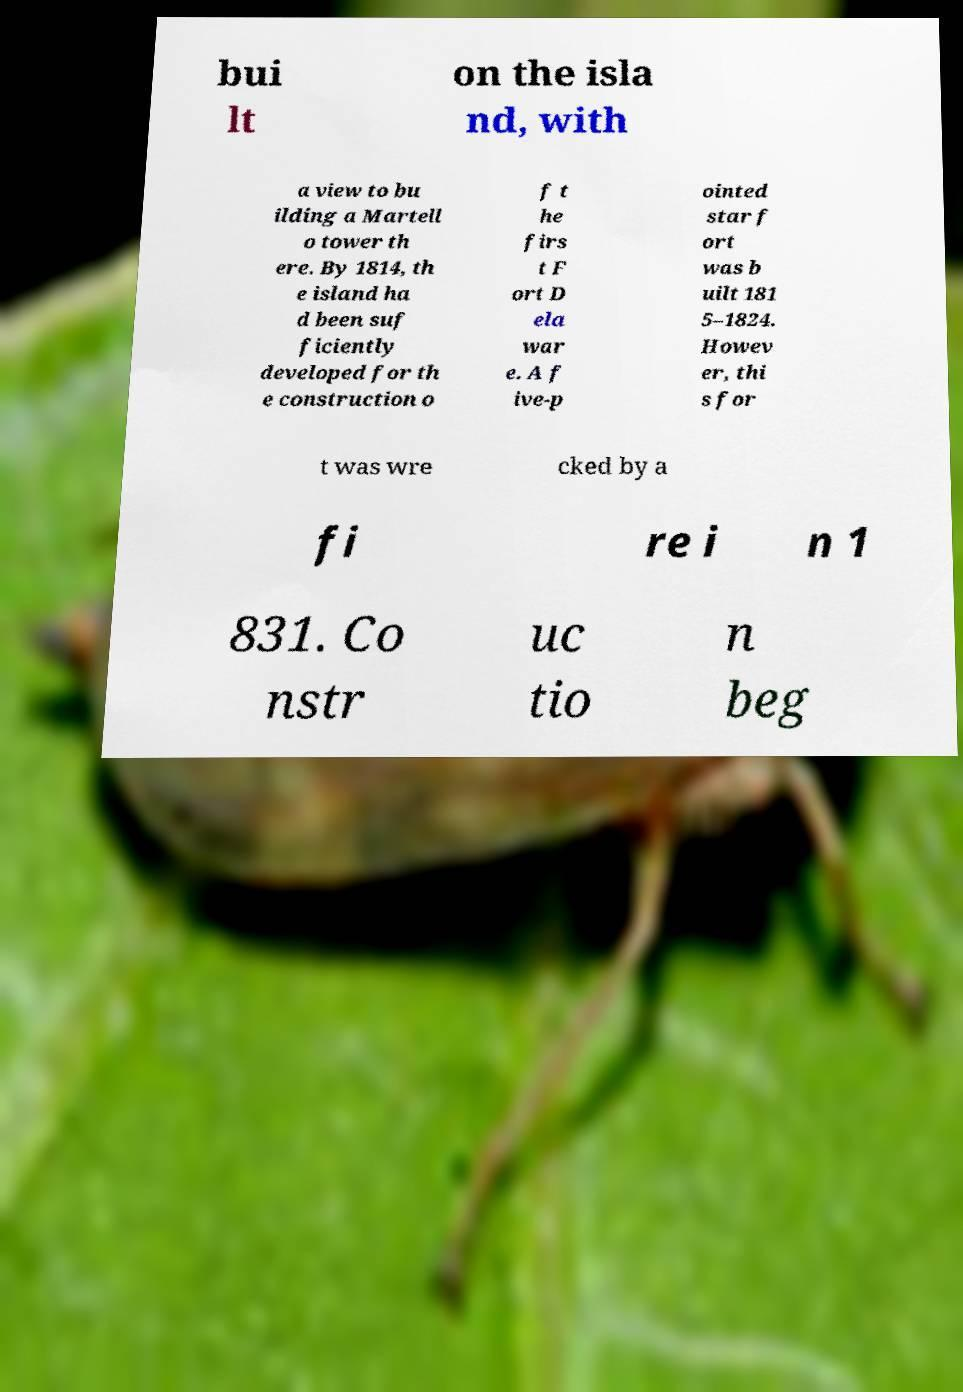Can you read and provide the text displayed in the image?This photo seems to have some interesting text. Can you extract and type it out for me? bui lt on the isla nd, with a view to bu ilding a Martell o tower th ere. By 1814, th e island ha d been suf ficiently developed for th e construction o f t he firs t F ort D ela war e. A f ive-p ointed star f ort was b uilt 181 5–1824. Howev er, thi s for t was wre cked by a fi re i n 1 831. Co nstr uc tio n beg 